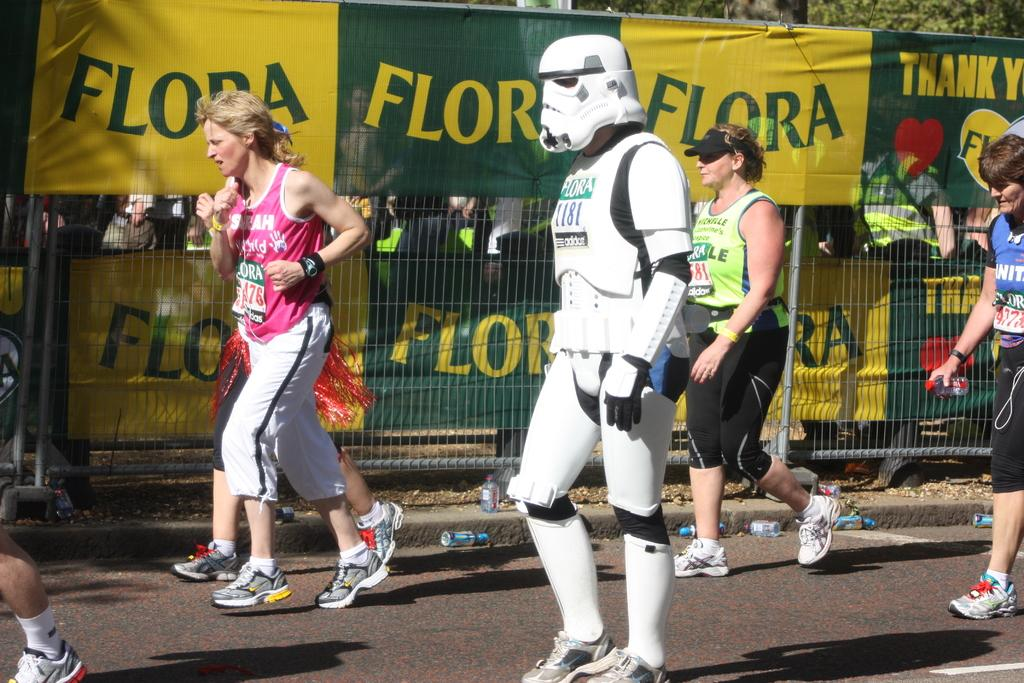What are the people in the image doing? The people in the image are jogging. What can be seen in the background of the image? In the background of the image, there is a fence, banners, and trees. Can you see the grandfather playing with spiders in the image? There is no grandfather or spiders present in the image. What type of potato is being used as a prop in the image? There is no potato present in the image. 